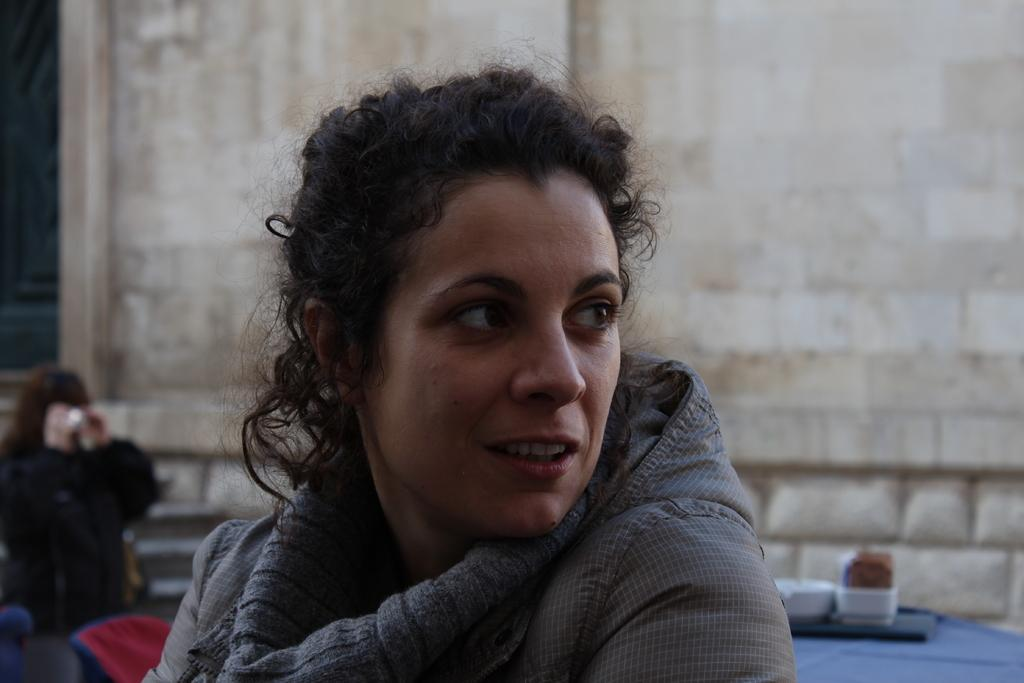What is the main subject of the image? There is a lady person in the image. What is the lady person wearing? The lady person is wearing a grey color jacket. Can you describe the person in the background? The person in the background is wearing a black color jacket. What can be seen behind the lady person? There is a wall visible in the image. How many pigs are visible in the image? There are no pigs present in the image. What type of brass instrument is the lady person playing in the image? There is no brass instrument visible in the image, and the lady person is not playing any instrument. 